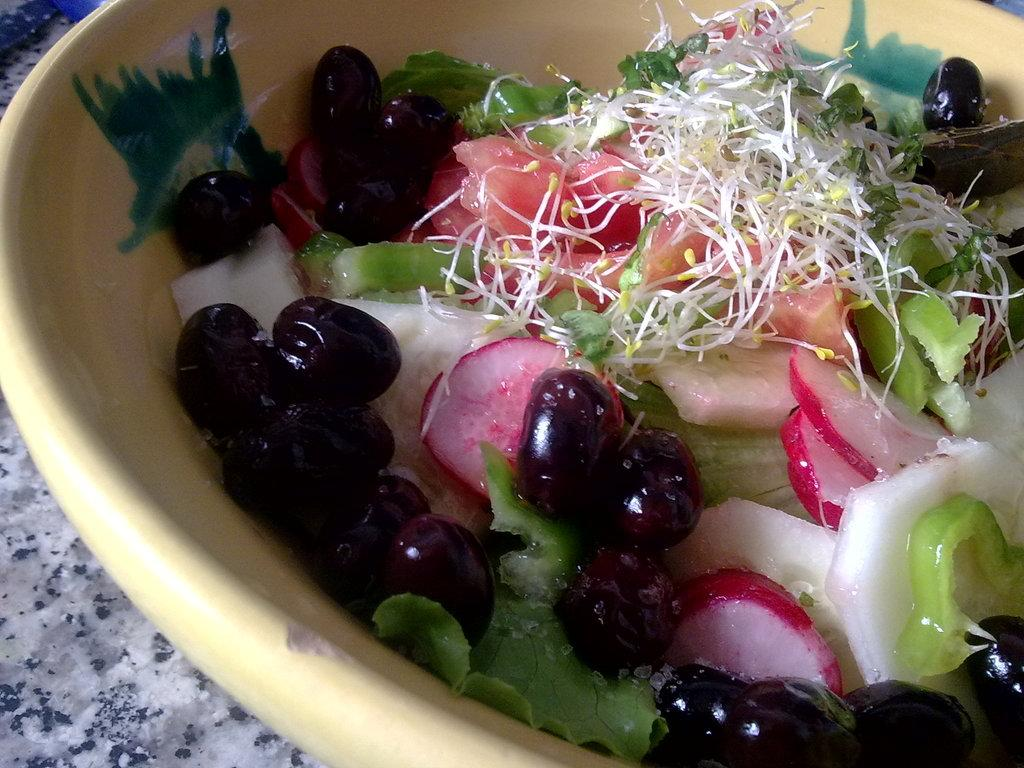What is located in the foreground of the image? There is a bowl in the foreground of the image. What is inside the bowl? The bowl contains salad. What type of furniture is present in the image? There is a table in the image. How many horses are visible in the image? There are no horses present in the image. What type of neck treatment is being performed on the salad? There is no neck treatment being performed on the salad, as it is a bowl of salad and not a person or animal. 